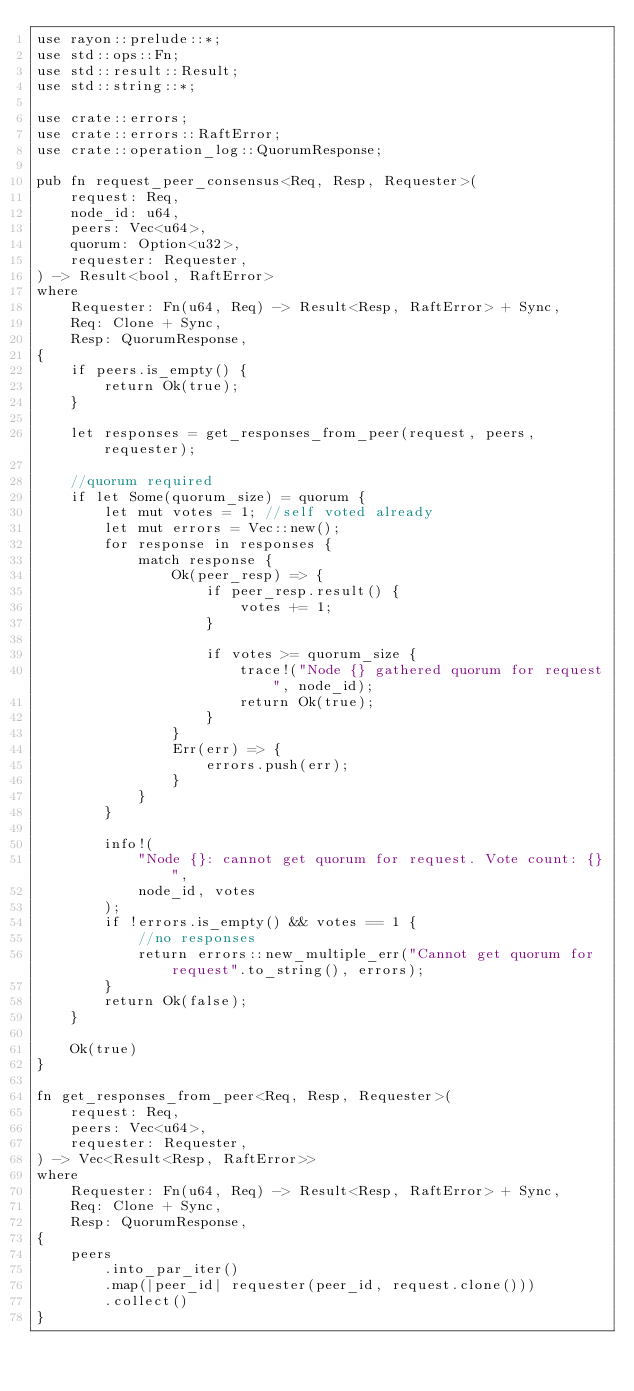Convert code to text. <code><loc_0><loc_0><loc_500><loc_500><_Rust_>use rayon::prelude::*;
use std::ops::Fn;
use std::result::Result;
use std::string::*;

use crate::errors;
use crate::errors::RaftError;
use crate::operation_log::QuorumResponse;

pub fn request_peer_consensus<Req, Resp, Requester>(
    request: Req,
    node_id: u64,
    peers: Vec<u64>,
    quorum: Option<u32>,
    requester: Requester,
) -> Result<bool, RaftError>
where
    Requester: Fn(u64, Req) -> Result<Resp, RaftError> + Sync,
    Req: Clone + Sync,
    Resp: QuorumResponse,
{
    if peers.is_empty() {
        return Ok(true);
    }

    let responses = get_responses_from_peer(request, peers, requester);

    //quorum required
    if let Some(quorum_size) = quorum {
        let mut votes = 1; //self voted already
        let mut errors = Vec::new();
        for response in responses {
            match response {
                Ok(peer_resp) => {
                    if peer_resp.result() {
                        votes += 1;
                    }

                    if votes >= quorum_size {
                        trace!("Node {} gathered quorum for request", node_id);
                        return Ok(true);
                    }
                }
                Err(err) => {
                    errors.push(err);
                }
            }
        }

        info!(
            "Node {}: cannot get quorum for request. Vote count: {}",
            node_id, votes
        );
        if !errors.is_empty() && votes == 1 {
            //no responses
            return errors::new_multiple_err("Cannot get quorum for request".to_string(), errors);
        }
        return Ok(false);
    }

    Ok(true)
}

fn get_responses_from_peer<Req, Resp, Requester>(
    request: Req,
    peers: Vec<u64>,
    requester: Requester,
) -> Vec<Result<Resp, RaftError>>
where
    Requester: Fn(u64, Req) -> Result<Resp, RaftError> + Sync,
    Req: Clone + Sync,
    Resp: QuorumResponse,
{
    peers
        .into_par_iter()
        .map(|peer_id| requester(peer_id, request.clone()))
        .collect()
}
</code> 